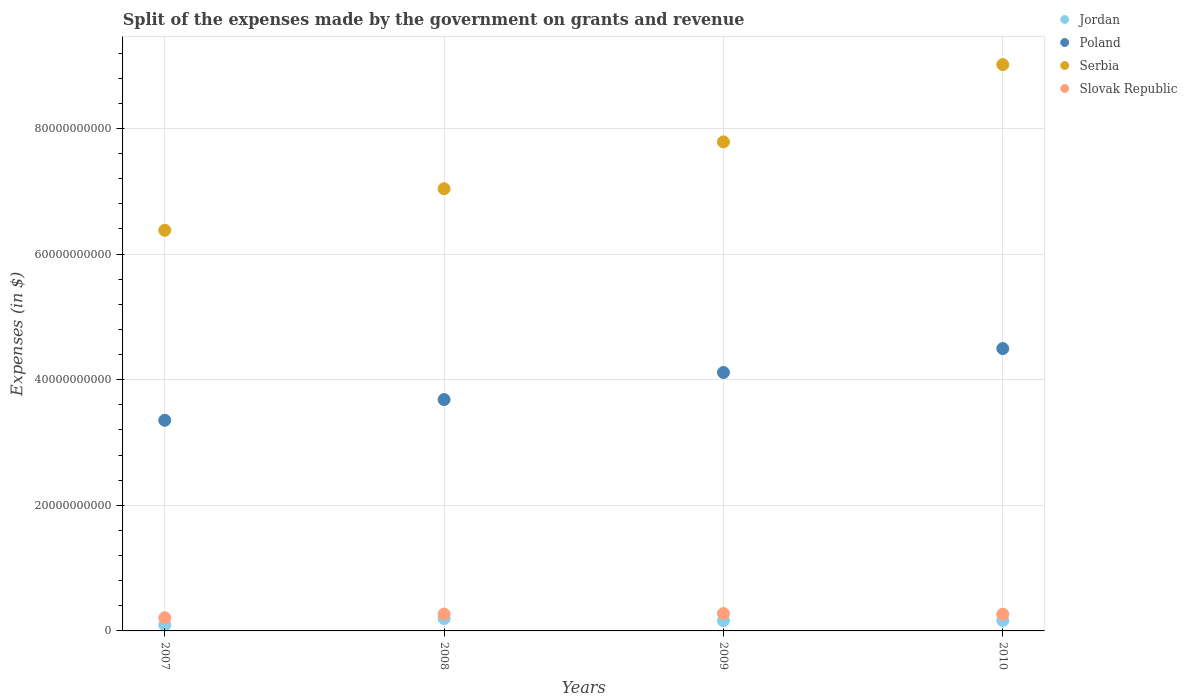Is the number of dotlines equal to the number of legend labels?
Give a very brief answer. Yes. What is the expenses made by the government on grants and revenue in Jordan in 2008?
Offer a very short reply. 1.96e+09. Across all years, what is the maximum expenses made by the government on grants and revenue in Poland?
Provide a succinct answer. 4.49e+1. Across all years, what is the minimum expenses made by the government on grants and revenue in Slovak Republic?
Ensure brevity in your answer.  2.09e+09. In which year was the expenses made by the government on grants and revenue in Serbia maximum?
Make the answer very short. 2010. What is the total expenses made by the government on grants and revenue in Slovak Republic in the graph?
Provide a short and direct response. 1.02e+1. What is the difference between the expenses made by the government on grants and revenue in Serbia in 2007 and that in 2010?
Your response must be concise. -2.64e+1. What is the difference between the expenses made by the government on grants and revenue in Jordan in 2007 and the expenses made by the government on grants and revenue in Serbia in 2010?
Your response must be concise. -8.92e+1. What is the average expenses made by the government on grants and revenue in Serbia per year?
Ensure brevity in your answer.  7.55e+1. In the year 2008, what is the difference between the expenses made by the government on grants and revenue in Slovak Republic and expenses made by the government on grants and revenue in Serbia?
Give a very brief answer. -6.77e+1. In how many years, is the expenses made by the government on grants and revenue in Serbia greater than 20000000000 $?
Your answer should be compact. 4. What is the ratio of the expenses made by the government on grants and revenue in Slovak Republic in 2007 to that in 2008?
Your answer should be compact. 0.78. Is the difference between the expenses made by the government on grants and revenue in Slovak Republic in 2009 and 2010 greater than the difference between the expenses made by the government on grants and revenue in Serbia in 2009 and 2010?
Provide a short and direct response. Yes. What is the difference between the highest and the second highest expenses made by the government on grants and revenue in Serbia?
Give a very brief answer. 1.23e+1. What is the difference between the highest and the lowest expenses made by the government on grants and revenue in Serbia?
Your answer should be compact. 2.64e+1. Is the sum of the expenses made by the government on grants and revenue in Slovak Republic in 2009 and 2010 greater than the maximum expenses made by the government on grants and revenue in Jordan across all years?
Ensure brevity in your answer.  Yes. Is it the case that in every year, the sum of the expenses made by the government on grants and revenue in Jordan and expenses made by the government on grants and revenue in Serbia  is greater than the sum of expenses made by the government on grants and revenue in Slovak Republic and expenses made by the government on grants and revenue in Poland?
Offer a terse response. No. Is the expenses made by the government on grants and revenue in Poland strictly less than the expenses made by the government on grants and revenue in Jordan over the years?
Your answer should be very brief. No. What is the difference between two consecutive major ticks on the Y-axis?
Provide a short and direct response. 2.00e+1. Are the values on the major ticks of Y-axis written in scientific E-notation?
Give a very brief answer. No. Does the graph contain any zero values?
Ensure brevity in your answer.  No. Does the graph contain grids?
Offer a terse response. Yes. Where does the legend appear in the graph?
Offer a terse response. Top right. How many legend labels are there?
Give a very brief answer. 4. How are the legend labels stacked?
Keep it short and to the point. Vertical. What is the title of the graph?
Make the answer very short. Split of the expenses made by the government on grants and revenue. What is the label or title of the X-axis?
Your answer should be very brief. Years. What is the label or title of the Y-axis?
Provide a short and direct response. Expenses (in $). What is the Expenses (in $) of Jordan in 2007?
Offer a terse response. 9.58e+08. What is the Expenses (in $) of Poland in 2007?
Give a very brief answer. 3.35e+1. What is the Expenses (in $) of Serbia in 2007?
Offer a terse response. 6.38e+1. What is the Expenses (in $) in Slovak Republic in 2007?
Provide a short and direct response. 2.09e+09. What is the Expenses (in $) in Jordan in 2008?
Keep it short and to the point. 1.96e+09. What is the Expenses (in $) of Poland in 2008?
Your response must be concise. 3.68e+1. What is the Expenses (in $) of Serbia in 2008?
Make the answer very short. 7.04e+1. What is the Expenses (in $) in Slovak Republic in 2008?
Your response must be concise. 2.68e+09. What is the Expenses (in $) of Jordan in 2009?
Your answer should be compact. 1.62e+09. What is the Expenses (in $) of Poland in 2009?
Offer a terse response. 4.11e+1. What is the Expenses (in $) in Serbia in 2009?
Ensure brevity in your answer.  7.79e+1. What is the Expenses (in $) of Slovak Republic in 2009?
Keep it short and to the point. 2.78e+09. What is the Expenses (in $) in Jordan in 2010?
Give a very brief answer. 1.66e+09. What is the Expenses (in $) of Poland in 2010?
Provide a short and direct response. 4.49e+1. What is the Expenses (in $) of Serbia in 2010?
Make the answer very short. 9.02e+1. What is the Expenses (in $) of Slovak Republic in 2010?
Your answer should be very brief. 2.66e+09. Across all years, what is the maximum Expenses (in $) of Jordan?
Your response must be concise. 1.96e+09. Across all years, what is the maximum Expenses (in $) of Poland?
Make the answer very short. 4.49e+1. Across all years, what is the maximum Expenses (in $) in Serbia?
Keep it short and to the point. 9.02e+1. Across all years, what is the maximum Expenses (in $) in Slovak Republic?
Your answer should be very brief. 2.78e+09. Across all years, what is the minimum Expenses (in $) in Jordan?
Give a very brief answer. 9.58e+08. Across all years, what is the minimum Expenses (in $) of Poland?
Provide a succinct answer. 3.35e+1. Across all years, what is the minimum Expenses (in $) in Serbia?
Make the answer very short. 6.38e+1. Across all years, what is the minimum Expenses (in $) of Slovak Republic?
Your answer should be very brief. 2.09e+09. What is the total Expenses (in $) of Jordan in the graph?
Make the answer very short. 6.19e+09. What is the total Expenses (in $) of Poland in the graph?
Your answer should be very brief. 1.56e+11. What is the total Expenses (in $) of Serbia in the graph?
Ensure brevity in your answer.  3.02e+11. What is the total Expenses (in $) in Slovak Republic in the graph?
Your response must be concise. 1.02e+1. What is the difference between the Expenses (in $) of Jordan in 2007 and that in 2008?
Offer a very short reply. -1.00e+09. What is the difference between the Expenses (in $) in Poland in 2007 and that in 2008?
Provide a succinct answer. -3.30e+09. What is the difference between the Expenses (in $) of Serbia in 2007 and that in 2008?
Make the answer very short. -6.62e+09. What is the difference between the Expenses (in $) of Slovak Republic in 2007 and that in 2008?
Your response must be concise. -5.94e+08. What is the difference between the Expenses (in $) of Jordan in 2007 and that in 2009?
Give a very brief answer. -6.63e+08. What is the difference between the Expenses (in $) of Poland in 2007 and that in 2009?
Your answer should be compact. -7.61e+09. What is the difference between the Expenses (in $) in Serbia in 2007 and that in 2009?
Provide a short and direct response. -1.41e+1. What is the difference between the Expenses (in $) of Slovak Republic in 2007 and that in 2009?
Make the answer very short. -6.87e+08. What is the difference between the Expenses (in $) of Jordan in 2007 and that in 2010?
Offer a very short reply. -6.98e+08. What is the difference between the Expenses (in $) of Poland in 2007 and that in 2010?
Ensure brevity in your answer.  -1.14e+1. What is the difference between the Expenses (in $) in Serbia in 2007 and that in 2010?
Offer a terse response. -2.64e+1. What is the difference between the Expenses (in $) in Slovak Republic in 2007 and that in 2010?
Offer a very short reply. -5.68e+08. What is the difference between the Expenses (in $) of Jordan in 2008 and that in 2009?
Offer a terse response. 3.38e+08. What is the difference between the Expenses (in $) in Poland in 2008 and that in 2009?
Make the answer very short. -4.31e+09. What is the difference between the Expenses (in $) of Serbia in 2008 and that in 2009?
Provide a succinct answer. -7.46e+09. What is the difference between the Expenses (in $) of Slovak Republic in 2008 and that in 2009?
Provide a short and direct response. -9.34e+07. What is the difference between the Expenses (in $) in Jordan in 2008 and that in 2010?
Make the answer very short. 3.03e+08. What is the difference between the Expenses (in $) of Poland in 2008 and that in 2010?
Provide a succinct answer. -8.12e+09. What is the difference between the Expenses (in $) of Serbia in 2008 and that in 2010?
Your answer should be compact. -1.98e+1. What is the difference between the Expenses (in $) in Slovak Republic in 2008 and that in 2010?
Make the answer very short. 2.63e+07. What is the difference between the Expenses (in $) of Jordan in 2009 and that in 2010?
Give a very brief answer. -3.53e+07. What is the difference between the Expenses (in $) of Poland in 2009 and that in 2010?
Provide a succinct answer. -3.81e+09. What is the difference between the Expenses (in $) in Serbia in 2009 and that in 2010?
Give a very brief answer. -1.23e+1. What is the difference between the Expenses (in $) of Slovak Republic in 2009 and that in 2010?
Offer a very short reply. 1.20e+08. What is the difference between the Expenses (in $) of Jordan in 2007 and the Expenses (in $) of Poland in 2008?
Make the answer very short. -3.59e+1. What is the difference between the Expenses (in $) in Jordan in 2007 and the Expenses (in $) in Serbia in 2008?
Give a very brief answer. -6.94e+1. What is the difference between the Expenses (in $) of Jordan in 2007 and the Expenses (in $) of Slovak Republic in 2008?
Your response must be concise. -1.73e+09. What is the difference between the Expenses (in $) in Poland in 2007 and the Expenses (in $) in Serbia in 2008?
Offer a very short reply. -3.69e+1. What is the difference between the Expenses (in $) in Poland in 2007 and the Expenses (in $) in Slovak Republic in 2008?
Make the answer very short. 3.08e+1. What is the difference between the Expenses (in $) of Serbia in 2007 and the Expenses (in $) of Slovak Republic in 2008?
Make the answer very short. 6.11e+1. What is the difference between the Expenses (in $) of Jordan in 2007 and the Expenses (in $) of Poland in 2009?
Your answer should be very brief. -4.02e+1. What is the difference between the Expenses (in $) of Jordan in 2007 and the Expenses (in $) of Serbia in 2009?
Keep it short and to the point. -7.69e+1. What is the difference between the Expenses (in $) in Jordan in 2007 and the Expenses (in $) in Slovak Republic in 2009?
Keep it short and to the point. -1.82e+09. What is the difference between the Expenses (in $) in Poland in 2007 and the Expenses (in $) in Serbia in 2009?
Provide a succinct answer. -4.43e+1. What is the difference between the Expenses (in $) in Poland in 2007 and the Expenses (in $) in Slovak Republic in 2009?
Provide a succinct answer. 3.08e+1. What is the difference between the Expenses (in $) of Serbia in 2007 and the Expenses (in $) of Slovak Republic in 2009?
Make the answer very short. 6.10e+1. What is the difference between the Expenses (in $) of Jordan in 2007 and the Expenses (in $) of Poland in 2010?
Ensure brevity in your answer.  -4.40e+1. What is the difference between the Expenses (in $) of Jordan in 2007 and the Expenses (in $) of Serbia in 2010?
Provide a succinct answer. -8.92e+1. What is the difference between the Expenses (in $) in Jordan in 2007 and the Expenses (in $) in Slovak Republic in 2010?
Keep it short and to the point. -1.70e+09. What is the difference between the Expenses (in $) of Poland in 2007 and the Expenses (in $) of Serbia in 2010?
Your response must be concise. -5.66e+1. What is the difference between the Expenses (in $) of Poland in 2007 and the Expenses (in $) of Slovak Republic in 2010?
Offer a terse response. 3.09e+1. What is the difference between the Expenses (in $) of Serbia in 2007 and the Expenses (in $) of Slovak Republic in 2010?
Your answer should be compact. 6.11e+1. What is the difference between the Expenses (in $) in Jordan in 2008 and the Expenses (in $) in Poland in 2009?
Your answer should be very brief. -3.92e+1. What is the difference between the Expenses (in $) in Jordan in 2008 and the Expenses (in $) in Serbia in 2009?
Give a very brief answer. -7.59e+1. What is the difference between the Expenses (in $) in Jordan in 2008 and the Expenses (in $) in Slovak Republic in 2009?
Ensure brevity in your answer.  -8.17e+08. What is the difference between the Expenses (in $) in Poland in 2008 and the Expenses (in $) in Serbia in 2009?
Make the answer very short. -4.10e+1. What is the difference between the Expenses (in $) of Poland in 2008 and the Expenses (in $) of Slovak Republic in 2009?
Make the answer very short. 3.41e+1. What is the difference between the Expenses (in $) in Serbia in 2008 and the Expenses (in $) in Slovak Republic in 2009?
Keep it short and to the point. 6.76e+1. What is the difference between the Expenses (in $) of Jordan in 2008 and the Expenses (in $) of Poland in 2010?
Make the answer very short. -4.30e+1. What is the difference between the Expenses (in $) of Jordan in 2008 and the Expenses (in $) of Serbia in 2010?
Give a very brief answer. -8.82e+1. What is the difference between the Expenses (in $) of Jordan in 2008 and the Expenses (in $) of Slovak Republic in 2010?
Ensure brevity in your answer.  -6.98e+08. What is the difference between the Expenses (in $) in Poland in 2008 and the Expenses (in $) in Serbia in 2010?
Ensure brevity in your answer.  -5.33e+1. What is the difference between the Expenses (in $) in Poland in 2008 and the Expenses (in $) in Slovak Republic in 2010?
Your answer should be compact. 3.42e+1. What is the difference between the Expenses (in $) of Serbia in 2008 and the Expenses (in $) of Slovak Republic in 2010?
Make the answer very short. 6.77e+1. What is the difference between the Expenses (in $) of Jordan in 2009 and the Expenses (in $) of Poland in 2010?
Your answer should be very brief. -4.33e+1. What is the difference between the Expenses (in $) in Jordan in 2009 and the Expenses (in $) in Serbia in 2010?
Your answer should be compact. -8.85e+1. What is the difference between the Expenses (in $) of Jordan in 2009 and the Expenses (in $) of Slovak Republic in 2010?
Make the answer very short. -1.04e+09. What is the difference between the Expenses (in $) of Poland in 2009 and the Expenses (in $) of Serbia in 2010?
Provide a succinct answer. -4.90e+1. What is the difference between the Expenses (in $) in Poland in 2009 and the Expenses (in $) in Slovak Republic in 2010?
Keep it short and to the point. 3.85e+1. What is the difference between the Expenses (in $) in Serbia in 2009 and the Expenses (in $) in Slovak Republic in 2010?
Ensure brevity in your answer.  7.52e+1. What is the average Expenses (in $) in Jordan per year?
Your response must be concise. 1.55e+09. What is the average Expenses (in $) of Poland per year?
Provide a short and direct response. 3.91e+1. What is the average Expenses (in $) in Serbia per year?
Your answer should be very brief. 7.55e+1. What is the average Expenses (in $) in Slovak Republic per year?
Offer a very short reply. 2.55e+09. In the year 2007, what is the difference between the Expenses (in $) in Jordan and Expenses (in $) in Poland?
Provide a short and direct response. -3.26e+1. In the year 2007, what is the difference between the Expenses (in $) in Jordan and Expenses (in $) in Serbia?
Give a very brief answer. -6.28e+1. In the year 2007, what is the difference between the Expenses (in $) in Jordan and Expenses (in $) in Slovak Republic?
Offer a terse response. -1.13e+09. In the year 2007, what is the difference between the Expenses (in $) of Poland and Expenses (in $) of Serbia?
Make the answer very short. -3.02e+1. In the year 2007, what is the difference between the Expenses (in $) in Poland and Expenses (in $) in Slovak Republic?
Your response must be concise. 3.14e+1. In the year 2007, what is the difference between the Expenses (in $) of Serbia and Expenses (in $) of Slovak Republic?
Offer a very short reply. 6.17e+1. In the year 2008, what is the difference between the Expenses (in $) in Jordan and Expenses (in $) in Poland?
Keep it short and to the point. -3.49e+1. In the year 2008, what is the difference between the Expenses (in $) of Jordan and Expenses (in $) of Serbia?
Your answer should be very brief. -6.84e+1. In the year 2008, what is the difference between the Expenses (in $) in Jordan and Expenses (in $) in Slovak Republic?
Ensure brevity in your answer.  -7.24e+08. In the year 2008, what is the difference between the Expenses (in $) in Poland and Expenses (in $) in Serbia?
Offer a very short reply. -3.36e+1. In the year 2008, what is the difference between the Expenses (in $) of Poland and Expenses (in $) of Slovak Republic?
Provide a succinct answer. 3.41e+1. In the year 2008, what is the difference between the Expenses (in $) of Serbia and Expenses (in $) of Slovak Republic?
Provide a succinct answer. 6.77e+1. In the year 2009, what is the difference between the Expenses (in $) in Jordan and Expenses (in $) in Poland?
Your answer should be compact. -3.95e+1. In the year 2009, what is the difference between the Expenses (in $) of Jordan and Expenses (in $) of Serbia?
Make the answer very short. -7.62e+1. In the year 2009, what is the difference between the Expenses (in $) of Jordan and Expenses (in $) of Slovak Republic?
Your answer should be very brief. -1.16e+09. In the year 2009, what is the difference between the Expenses (in $) in Poland and Expenses (in $) in Serbia?
Keep it short and to the point. -3.67e+1. In the year 2009, what is the difference between the Expenses (in $) in Poland and Expenses (in $) in Slovak Republic?
Your response must be concise. 3.84e+1. In the year 2009, what is the difference between the Expenses (in $) of Serbia and Expenses (in $) of Slovak Republic?
Your answer should be compact. 7.51e+1. In the year 2010, what is the difference between the Expenses (in $) of Jordan and Expenses (in $) of Poland?
Ensure brevity in your answer.  -4.33e+1. In the year 2010, what is the difference between the Expenses (in $) of Jordan and Expenses (in $) of Serbia?
Give a very brief answer. -8.85e+1. In the year 2010, what is the difference between the Expenses (in $) in Jordan and Expenses (in $) in Slovak Republic?
Offer a very short reply. -1.00e+09. In the year 2010, what is the difference between the Expenses (in $) of Poland and Expenses (in $) of Serbia?
Offer a very short reply. -4.52e+1. In the year 2010, what is the difference between the Expenses (in $) of Poland and Expenses (in $) of Slovak Republic?
Give a very brief answer. 4.23e+1. In the year 2010, what is the difference between the Expenses (in $) in Serbia and Expenses (in $) in Slovak Republic?
Provide a short and direct response. 8.75e+1. What is the ratio of the Expenses (in $) in Jordan in 2007 to that in 2008?
Ensure brevity in your answer.  0.49. What is the ratio of the Expenses (in $) in Poland in 2007 to that in 2008?
Make the answer very short. 0.91. What is the ratio of the Expenses (in $) of Serbia in 2007 to that in 2008?
Your answer should be compact. 0.91. What is the ratio of the Expenses (in $) in Slovak Republic in 2007 to that in 2008?
Your response must be concise. 0.78. What is the ratio of the Expenses (in $) in Jordan in 2007 to that in 2009?
Your response must be concise. 0.59. What is the ratio of the Expenses (in $) of Poland in 2007 to that in 2009?
Provide a succinct answer. 0.82. What is the ratio of the Expenses (in $) of Serbia in 2007 to that in 2009?
Give a very brief answer. 0.82. What is the ratio of the Expenses (in $) in Slovak Republic in 2007 to that in 2009?
Your answer should be compact. 0.75. What is the ratio of the Expenses (in $) of Jordan in 2007 to that in 2010?
Provide a short and direct response. 0.58. What is the ratio of the Expenses (in $) in Poland in 2007 to that in 2010?
Give a very brief answer. 0.75. What is the ratio of the Expenses (in $) in Serbia in 2007 to that in 2010?
Provide a short and direct response. 0.71. What is the ratio of the Expenses (in $) of Slovak Republic in 2007 to that in 2010?
Your answer should be very brief. 0.79. What is the ratio of the Expenses (in $) of Jordan in 2008 to that in 2009?
Offer a terse response. 1.21. What is the ratio of the Expenses (in $) of Poland in 2008 to that in 2009?
Offer a very short reply. 0.9. What is the ratio of the Expenses (in $) of Serbia in 2008 to that in 2009?
Your response must be concise. 0.9. What is the ratio of the Expenses (in $) of Slovak Republic in 2008 to that in 2009?
Keep it short and to the point. 0.97. What is the ratio of the Expenses (in $) in Jordan in 2008 to that in 2010?
Your answer should be compact. 1.18. What is the ratio of the Expenses (in $) of Poland in 2008 to that in 2010?
Your answer should be very brief. 0.82. What is the ratio of the Expenses (in $) of Serbia in 2008 to that in 2010?
Offer a terse response. 0.78. What is the ratio of the Expenses (in $) of Slovak Republic in 2008 to that in 2010?
Your answer should be compact. 1.01. What is the ratio of the Expenses (in $) in Jordan in 2009 to that in 2010?
Offer a terse response. 0.98. What is the ratio of the Expenses (in $) of Poland in 2009 to that in 2010?
Keep it short and to the point. 0.92. What is the ratio of the Expenses (in $) in Serbia in 2009 to that in 2010?
Make the answer very short. 0.86. What is the ratio of the Expenses (in $) of Slovak Republic in 2009 to that in 2010?
Your response must be concise. 1.05. What is the difference between the highest and the second highest Expenses (in $) in Jordan?
Ensure brevity in your answer.  3.03e+08. What is the difference between the highest and the second highest Expenses (in $) in Poland?
Offer a very short reply. 3.81e+09. What is the difference between the highest and the second highest Expenses (in $) in Serbia?
Provide a succinct answer. 1.23e+1. What is the difference between the highest and the second highest Expenses (in $) in Slovak Republic?
Make the answer very short. 9.34e+07. What is the difference between the highest and the lowest Expenses (in $) in Jordan?
Make the answer very short. 1.00e+09. What is the difference between the highest and the lowest Expenses (in $) of Poland?
Your answer should be compact. 1.14e+1. What is the difference between the highest and the lowest Expenses (in $) in Serbia?
Ensure brevity in your answer.  2.64e+1. What is the difference between the highest and the lowest Expenses (in $) in Slovak Republic?
Keep it short and to the point. 6.87e+08. 